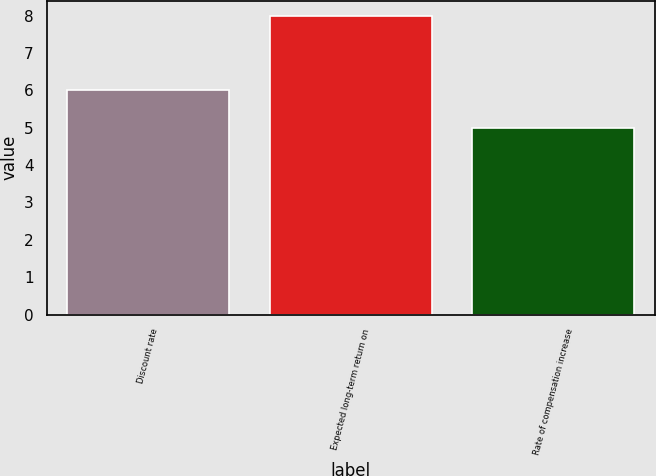Convert chart. <chart><loc_0><loc_0><loc_500><loc_500><bar_chart><fcel>Discount rate<fcel>Expected long-term return on<fcel>Rate of compensation increase<nl><fcel>6<fcel>8<fcel>5<nl></chart> 